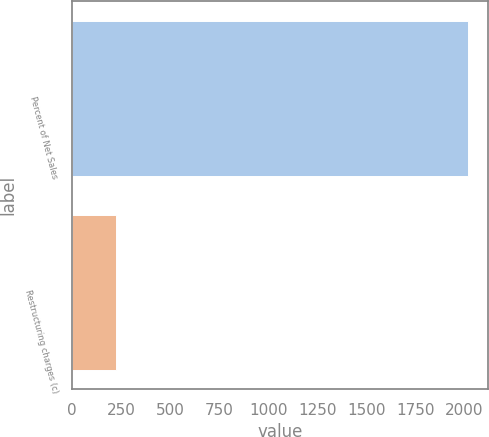Convert chart. <chart><loc_0><loc_0><loc_500><loc_500><bar_chart><fcel>Percent of Net Sales<fcel>Restructuring charges (c)<nl><fcel>2017<fcel>221.9<nl></chart> 